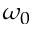Convert formula to latex. <formula><loc_0><loc_0><loc_500><loc_500>\omega _ { 0 }</formula> 